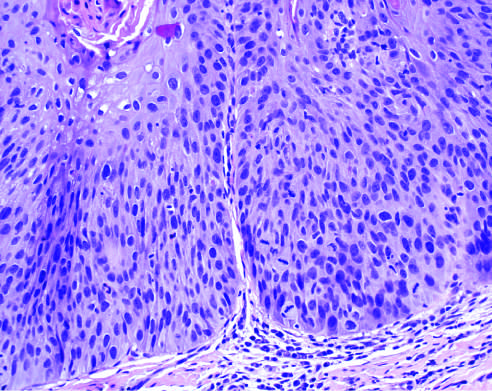what is dysplasia characterized by?
Answer the question using a single word or phrase. Nuclear and cellular pleomorphism and loss of normal maturation 